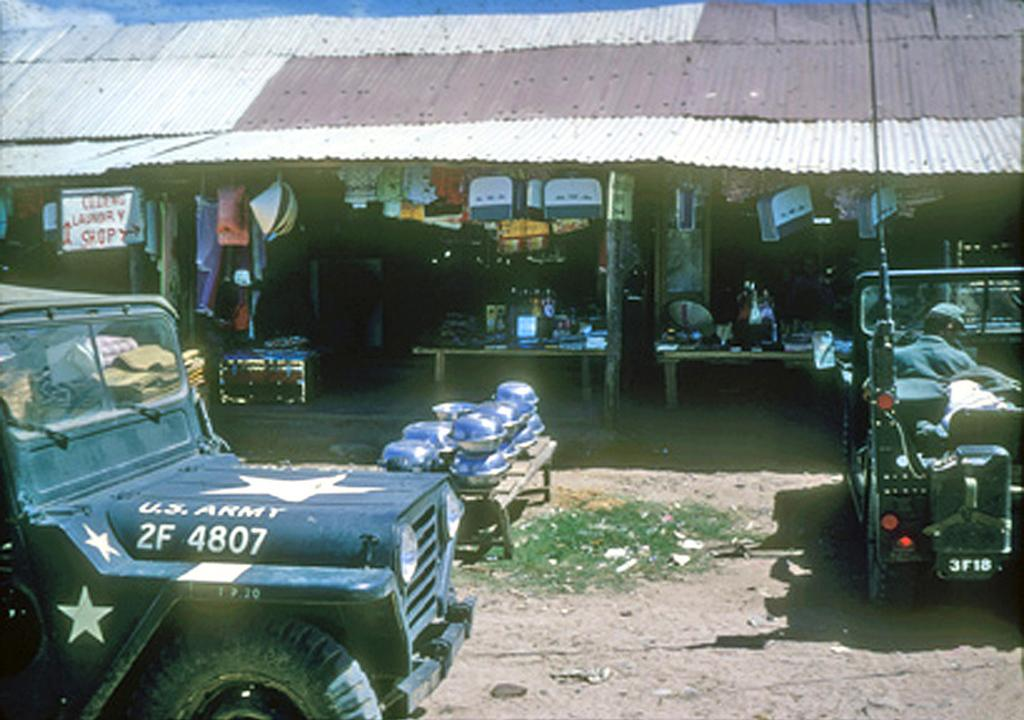What type of structure is present in the image? There are stores under a shed in the image. Are there any vehicles visible in the image? Yes, there are two vehicles in front of the stores. Can you describe the second vehicle? In the second vehicle, there is a man sitting in front of the steering wheel. What type of ball is being used by the man in the second vehicle? There is no ball present in the image; the man is sitting in front of the steering wheel of the vehicle. 